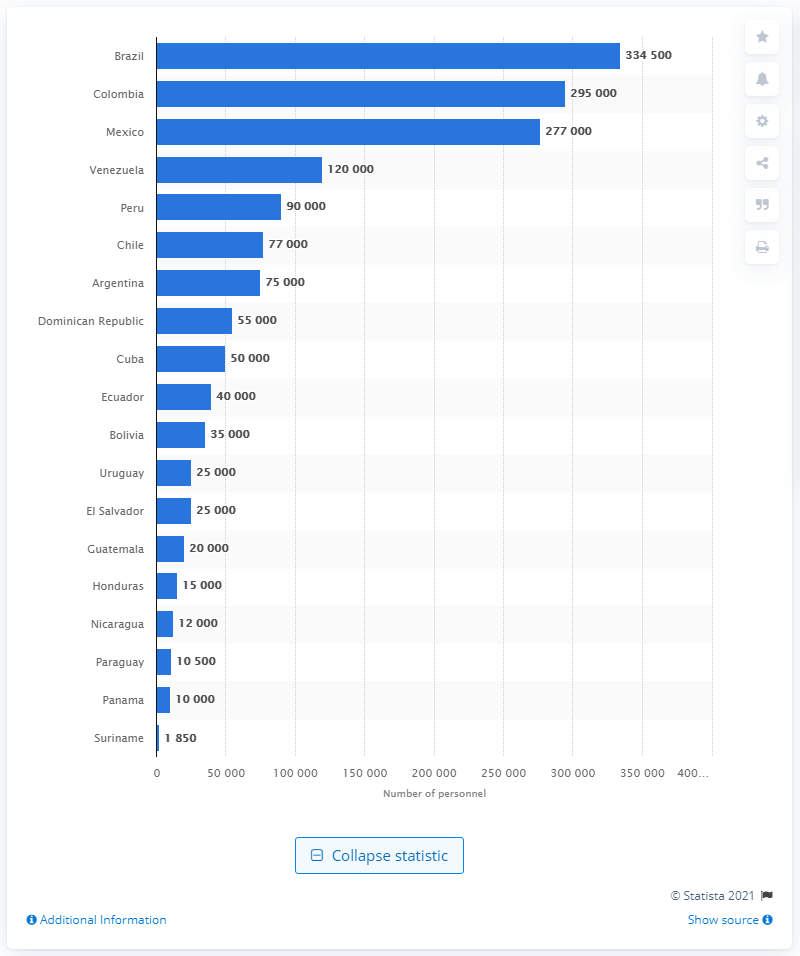Specify some key components in this picture. Brazil has the most active military personnel in Latin America and the Caribbean. 